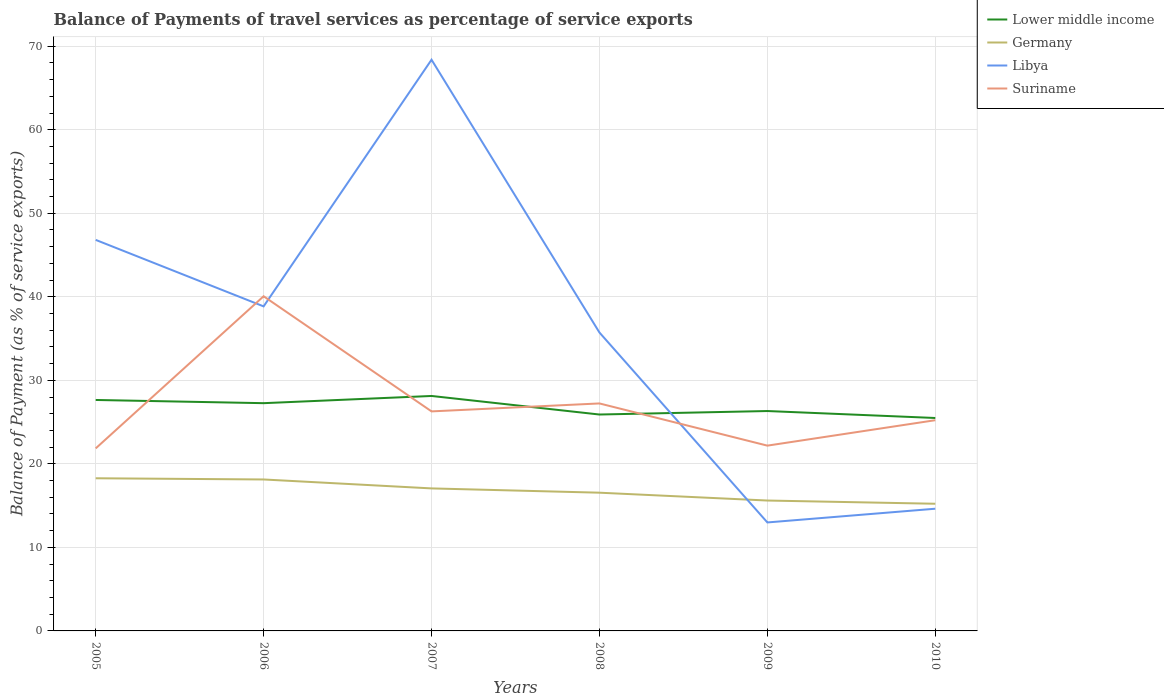Across all years, what is the maximum balance of payments of travel services in Germany?
Provide a short and direct response. 15.23. What is the total balance of payments of travel services in Lower middle income in the graph?
Offer a very short reply. 2.64. What is the difference between the highest and the second highest balance of payments of travel services in Suriname?
Your answer should be very brief. 18.22. Is the balance of payments of travel services in Libya strictly greater than the balance of payments of travel services in Lower middle income over the years?
Provide a succinct answer. No. How many lines are there?
Your answer should be compact. 4. What is the difference between two consecutive major ticks on the Y-axis?
Your answer should be very brief. 10. Are the values on the major ticks of Y-axis written in scientific E-notation?
Offer a terse response. No. Does the graph contain any zero values?
Ensure brevity in your answer.  No. Does the graph contain grids?
Offer a terse response. Yes. Where does the legend appear in the graph?
Ensure brevity in your answer.  Top right. How many legend labels are there?
Provide a succinct answer. 4. What is the title of the graph?
Ensure brevity in your answer.  Balance of Payments of travel services as percentage of service exports. What is the label or title of the X-axis?
Make the answer very short. Years. What is the label or title of the Y-axis?
Your answer should be compact. Balance of Payment (as % of service exports). What is the Balance of Payment (as % of service exports) in Lower middle income in 2005?
Your response must be concise. 27.65. What is the Balance of Payment (as % of service exports) in Germany in 2005?
Keep it short and to the point. 18.28. What is the Balance of Payment (as % of service exports) in Libya in 2005?
Keep it short and to the point. 46.82. What is the Balance of Payment (as % of service exports) in Suriname in 2005?
Make the answer very short. 21.85. What is the Balance of Payment (as % of service exports) of Lower middle income in 2006?
Your answer should be compact. 27.27. What is the Balance of Payment (as % of service exports) in Germany in 2006?
Ensure brevity in your answer.  18.13. What is the Balance of Payment (as % of service exports) in Libya in 2006?
Your response must be concise. 38.85. What is the Balance of Payment (as % of service exports) of Suriname in 2006?
Your answer should be very brief. 40.07. What is the Balance of Payment (as % of service exports) in Lower middle income in 2007?
Provide a short and direct response. 28.13. What is the Balance of Payment (as % of service exports) of Germany in 2007?
Your answer should be very brief. 17.06. What is the Balance of Payment (as % of service exports) in Libya in 2007?
Your answer should be very brief. 68.39. What is the Balance of Payment (as % of service exports) of Suriname in 2007?
Offer a very short reply. 26.28. What is the Balance of Payment (as % of service exports) in Lower middle income in 2008?
Provide a short and direct response. 25.91. What is the Balance of Payment (as % of service exports) in Germany in 2008?
Your response must be concise. 16.55. What is the Balance of Payment (as % of service exports) of Libya in 2008?
Give a very brief answer. 35.72. What is the Balance of Payment (as % of service exports) in Suriname in 2008?
Provide a succinct answer. 27.23. What is the Balance of Payment (as % of service exports) in Lower middle income in 2009?
Offer a very short reply. 26.33. What is the Balance of Payment (as % of service exports) of Germany in 2009?
Give a very brief answer. 15.61. What is the Balance of Payment (as % of service exports) in Libya in 2009?
Provide a succinct answer. 12.99. What is the Balance of Payment (as % of service exports) in Suriname in 2009?
Keep it short and to the point. 22.18. What is the Balance of Payment (as % of service exports) in Lower middle income in 2010?
Ensure brevity in your answer.  25.49. What is the Balance of Payment (as % of service exports) in Germany in 2010?
Keep it short and to the point. 15.23. What is the Balance of Payment (as % of service exports) in Libya in 2010?
Offer a terse response. 14.63. What is the Balance of Payment (as % of service exports) in Suriname in 2010?
Offer a terse response. 25.23. Across all years, what is the maximum Balance of Payment (as % of service exports) in Lower middle income?
Offer a very short reply. 28.13. Across all years, what is the maximum Balance of Payment (as % of service exports) of Germany?
Your response must be concise. 18.28. Across all years, what is the maximum Balance of Payment (as % of service exports) of Libya?
Keep it short and to the point. 68.39. Across all years, what is the maximum Balance of Payment (as % of service exports) of Suriname?
Your answer should be compact. 40.07. Across all years, what is the minimum Balance of Payment (as % of service exports) in Lower middle income?
Your answer should be very brief. 25.49. Across all years, what is the minimum Balance of Payment (as % of service exports) of Germany?
Make the answer very short. 15.23. Across all years, what is the minimum Balance of Payment (as % of service exports) in Libya?
Ensure brevity in your answer.  12.99. Across all years, what is the minimum Balance of Payment (as % of service exports) in Suriname?
Keep it short and to the point. 21.85. What is the total Balance of Payment (as % of service exports) in Lower middle income in the graph?
Offer a terse response. 160.78. What is the total Balance of Payment (as % of service exports) in Germany in the graph?
Your answer should be compact. 100.86. What is the total Balance of Payment (as % of service exports) of Libya in the graph?
Offer a terse response. 217.4. What is the total Balance of Payment (as % of service exports) of Suriname in the graph?
Ensure brevity in your answer.  162.85. What is the difference between the Balance of Payment (as % of service exports) in Lower middle income in 2005 and that in 2006?
Offer a terse response. 0.38. What is the difference between the Balance of Payment (as % of service exports) in Germany in 2005 and that in 2006?
Your answer should be very brief. 0.14. What is the difference between the Balance of Payment (as % of service exports) in Libya in 2005 and that in 2006?
Offer a terse response. 7.96. What is the difference between the Balance of Payment (as % of service exports) of Suriname in 2005 and that in 2006?
Ensure brevity in your answer.  -18.22. What is the difference between the Balance of Payment (as % of service exports) of Lower middle income in 2005 and that in 2007?
Offer a terse response. -0.48. What is the difference between the Balance of Payment (as % of service exports) in Germany in 2005 and that in 2007?
Keep it short and to the point. 1.21. What is the difference between the Balance of Payment (as % of service exports) in Libya in 2005 and that in 2007?
Offer a terse response. -21.57. What is the difference between the Balance of Payment (as % of service exports) in Suriname in 2005 and that in 2007?
Give a very brief answer. -4.43. What is the difference between the Balance of Payment (as % of service exports) in Lower middle income in 2005 and that in 2008?
Your answer should be very brief. 1.74. What is the difference between the Balance of Payment (as % of service exports) of Germany in 2005 and that in 2008?
Offer a terse response. 1.73. What is the difference between the Balance of Payment (as % of service exports) of Libya in 2005 and that in 2008?
Provide a succinct answer. 11.09. What is the difference between the Balance of Payment (as % of service exports) of Suriname in 2005 and that in 2008?
Provide a short and direct response. -5.38. What is the difference between the Balance of Payment (as % of service exports) in Lower middle income in 2005 and that in 2009?
Offer a very short reply. 1.32. What is the difference between the Balance of Payment (as % of service exports) of Germany in 2005 and that in 2009?
Your answer should be compact. 2.67. What is the difference between the Balance of Payment (as % of service exports) of Libya in 2005 and that in 2009?
Your answer should be compact. 33.83. What is the difference between the Balance of Payment (as % of service exports) of Suriname in 2005 and that in 2009?
Ensure brevity in your answer.  -0.33. What is the difference between the Balance of Payment (as % of service exports) of Lower middle income in 2005 and that in 2010?
Your answer should be very brief. 2.16. What is the difference between the Balance of Payment (as % of service exports) in Germany in 2005 and that in 2010?
Keep it short and to the point. 3.05. What is the difference between the Balance of Payment (as % of service exports) in Libya in 2005 and that in 2010?
Offer a very short reply. 32.19. What is the difference between the Balance of Payment (as % of service exports) of Suriname in 2005 and that in 2010?
Offer a terse response. -3.38. What is the difference between the Balance of Payment (as % of service exports) of Lower middle income in 2006 and that in 2007?
Your answer should be compact. -0.86. What is the difference between the Balance of Payment (as % of service exports) in Germany in 2006 and that in 2007?
Give a very brief answer. 1.07. What is the difference between the Balance of Payment (as % of service exports) in Libya in 2006 and that in 2007?
Give a very brief answer. -29.53. What is the difference between the Balance of Payment (as % of service exports) of Suriname in 2006 and that in 2007?
Your response must be concise. 13.79. What is the difference between the Balance of Payment (as % of service exports) of Lower middle income in 2006 and that in 2008?
Offer a terse response. 1.36. What is the difference between the Balance of Payment (as % of service exports) in Germany in 2006 and that in 2008?
Provide a short and direct response. 1.58. What is the difference between the Balance of Payment (as % of service exports) of Libya in 2006 and that in 2008?
Your answer should be very brief. 3.13. What is the difference between the Balance of Payment (as % of service exports) of Suriname in 2006 and that in 2008?
Keep it short and to the point. 12.83. What is the difference between the Balance of Payment (as % of service exports) of Lower middle income in 2006 and that in 2009?
Give a very brief answer. 0.94. What is the difference between the Balance of Payment (as % of service exports) of Germany in 2006 and that in 2009?
Your answer should be very brief. 2.52. What is the difference between the Balance of Payment (as % of service exports) in Libya in 2006 and that in 2009?
Offer a very short reply. 25.87. What is the difference between the Balance of Payment (as % of service exports) of Suriname in 2006 and that in 2009?
Make the answer very short. 17.88. What is the difference between the Balance of Payment (as % of service exports) of Lower middle income in 2006 and that in 2010?
Give a very brief answer. 1.77. What is the difference between the Balance of Payment (as % of service exports) of Germany in 2006 and that in 2010?
Make the answer very short. 2.91. What is the difference between the Balance of Payment (as % of service exports) in Libya in 2006 and that in 2010?
Your response must be concise. 24.22. What is the difference between the Balance of Payment (as % of service exports) of Suriname in 2006 and that in 2010?
Offer a terse response. 14.84. What is the difference between the Balance of Payment (as % of service exports) of Lower middle income in 2007 and that in 2008?
Your answer should be compact. 2.22. What is the difference between the Balance of Payment (as % of service exports) of Germany in 2007 and that in 2008?
Your response must be concise. 0.51. What is the difference between the Balance of Payment (as % of service exports) in Libya in 2007 and that in 2008?
Offer a very short reply. 32.66. What is the difference between the Balance of Payment (as % of service exports) of Suriname in 2007 and that in 2008?
Offer a terse response. -0.95. What is the difference between the Balance of Payment (as % of service exports) in Lower middle income in 2007 and that in 2009?
Make the answer very short. 1.8. What is the difference between the Balance of Payment (as % of service exports) in Germany in 2007 and that in 2009?
Your answer should be compact. 1.45. What is the difference between the Balance of Payment (as % of service exports) of Libya in 2007 and that in 2009?
Make the answer very short. 55.4. What is the difference between the Balance of Payment (as % of service exports) in Suriname in 2007 and that in 2009?
Give a very brief answer. 4.1. What is the difference between the Balance of Payment (as % of service exports) in Lower middle income in 2007 and that in 2010?
Offer a very short reply. 2.64. What is the difference between the Balance of Payment (as % of service exports) in Germany in 2007 and that in 2010?
Offer a very short reply. 1.84. What is the difference between the Balance of Payment (as % of service exports) of Libya in 2007 and that in 2010?
Your answer should be very brief. 53.76. What is the difference between the Balance of Payment (as % of service exports) of Suriname in 2007 and that in 2010?
Your response must be concise. 1.05. What is the difference between the Balance of Payment (as % of service exports) in Lower middle income in 2008 and that in 2009?
Offer a very short reply. -0.42. What is the difference between the Balance of Payment (as % of service exports) in Germany in 2008 and that in 2009?
Your answer should be compact. 0.94. What is the difference between the Balance of Payment (as % of service exports) in Libya in 2008 and that in 2009?
Offer a terse response. 22.74. What is the difference between the Balance of Payment (as % of service exports) of Suriname in 2008 and that in 2009?
Ensure brevity in your answer.  5.05. What is the difference between the Balance of Payment (as % of service exports) of Lower middle income in 2008 and that in 2010?
Provide a succinct answer. 0.42. What is the difference between the Balance of Payment (as % of service exports) in Germany in 2008 and that in 2010?
Your response must be concise. 1.32. What is the difference between the Balance of Payment (as % of service exports) in Libya in 2008 and that in 2010?
Make the answer very short. 21.09. What is the difference between the Balance of Payment (as % of service exports) in Suriname in 2008 and that in 2010?
Offer a terse response. 2.01. What is the difference between the Balance of Payment (as % of service exports) in Lower middle income in 2009 and that in 2010?
Offer a terse response. 0.83. What is the difference between the Balance of Payment (as % of service exports) of Germany in 2009 and that in 2010?
Make the answer very short. 0.38. What is the difference between the Balance of Payment (as % of service exports) of Libya in 2009 and that in 2010?
Your answer should be very brief. -1.64. What is the difference between the Balance of Payment (as % of service exports) in Suriname in 2009 and that in 2010?
Offer a very short reply. -3.04. What is the difference between the Balance of Payment (as % of service exports) of Lower middle income in 2005 and the Balance of Payment (as % of service exports) of Germany in 2006?
Your answer should be compact. 9.52. What is the difference between the Balance of Payment (as % of service exports) in Lower middle income in 2005 and the Balance of Payment (as % of service exports) in Libya in 2006?
Offer a terse response. -11.2. What is the difference between the Balance of Payment (as % of service exports) of Lower middle income in 2005 and the Balance of Payment (as % of service exports) of Suriname in 2006?
Your answer should be very brief. -12.42. What is the difference between the Balance of Payment (as % of service exports) of Germany in 2005 and the Balance of Payment (as % of service exports) of Libya in 2006?
Keep it short and to the point. -20.58. What is the difference between the Balance of Payment (as % of service exports) of Germany in 2005 and the Balance of Payment (as % of service exports) of Suriname in 2006?
Keep it short and to the point. -21.79. What is the difference between the Balance of Payment (as % of service exports) in Libya in 2005 and the Balance of Payment (as % of service exports) in Suriname in 2006?
Provide a succinct answer. 6.75. What is the difference between the Balance of Payment (as % of service exports) of Lower middle income in 2005 and the Balance of Payment (as % of service exports) of Germany in 2007?
Your answer should be compact. 10.59. What is the difference between the Balance of Payment (as % of service exports) in Lower middle income in 2005 and the Balance of Payment (as % of service exports) in Libya in 2007?
Keep it short and to the point. -40.74. What is the difference between the Balance of Payment (as % of service exports) of Lower middle income in 2005 and the Balance of Payment (as % of service exports) of Suriname in 2007?
Give a very brief answer. 1.37. What is the difference between the Balance of Payment (as % of service exports) of Germany in 2005 and the Balance of Payment (as % of service exports) of Libya in 2007?
Your answer should be very brief. -50.11. What is the difference between the Balance of Payment (as % of service exports) in Germany in 2005 and the Balance of Payment (as % of service exports) in Suriname in 2007?
Your response must be concise. -8.01. What is the difference between the Balance of Payment (as % of service exports) of Libya in 2005 and the Balance of Payment (as % of service exports) of Suriname in 2007?
Your response must be concise. 20.53. What is the difference between the Balance of Payment (as % of service exports) in Lower middle income in 2005 and the Balance of Payment (as % of service exports) in Germany in 2008?
Give a very brief answer. 11.1. What is the difference between the Balance of Payment (as % of service exports) of Lower middle income in 2005 and the Balance of Payment (as % of service exports) of Libya in 2008?
Provide a short and direct response. -8.07. What is the difference between the Balance of Payment (as % of service exports) in Lower middle income in 2005 and the Balance of Payment (as % of service exports) in Suriname in 2008?
Offer a very short reply. 0.42. What is the difference between the Balance of Payment (as % of service exports) in Germany in 2005 and the Balance of Payment (as % of service exports) in Libya in 2008?
Provide a short and direct response. -17.45. What is the difference between the Balance of Payment (as % of service exports) in Germany in 2005 and the Balance of Payment (as % of service exports) in Suriname in 2008?
Provide a short and direct response. -8.96. What is the difference between the Balance of Payment (as % of service exports) of Libya in 2005 and the Balance of Payment (as % of service exports) of Suriname in 2008?
Ensure brevity in your answer.  19.58. What is the difference between the Balance of Payment (as % of service exports) in Lower middle income in 2005 and the Balance of Payment (as % of service exports) in Germany in 2009?
Keep it short and to the point. 12.04. What is the difference between the Balance of Payment (as % of service exports) in Lower middle income in 2005 and the Balance of Payment (as % of service exports) in Libya in 2009?
Your response must be concise. 14.66. What is the difference between the Balance of Payment (as % of service exports) in Lower middle income in 2005 and the Balance of Payment (as % of service exports) in Suriname in 2009?
Provide a short and direct response. 5.47. What is the difference between the Balance of Payment (as % of service exports) in Germany in 2005 and the Balance of Payment (as % of service exports) in Libya in 2009?
Your answer should be compact. 5.29. What is the difference between the Balance of Payment (as % of service exports) of Germany in 2005 and the Balance of Payment (as % of service exports) of Suriname in 2009?
Provide a short and direct response. -3.91. What is the difference between the Balance of Payment (as % of service exports) in Libya in 2005 and the Balance of Payment (as % of service exports) in Suriname in 2009?
Ensure brevity in your answer.  24.63. What is the difference between the Balance of Payment (as % of service exports) of Lower middle income in 2005 and the Balance of Payment (as % of service exports) of Germany in 2010?
Your answer should be very brief. 12.43. What is the difference between the Balance of Payment (as % of service exports) of Lower middle income in 2005 and the Balance of Payment (as % of service exports) of Libya in 2010?
Your response must be concise. 13.02. What is the difference between the Balance of Payment (as % of service exports) of Lower middle income in 2005 and the Balance of Payment (as % of service exports) of Suriname in 2010?
Your response must be concise. 2.42. What is the difference between the Balance of Payment (as % of service exports) in Germany in 2005 and the Balance of Payment (as % of service exports) in Libya in 2010?
Make the answer very short. 3.65. What is the difference between the Balance of Payment (as % of service exports) of Germany in 2005 and the Balance of Payment (as % of service exports) of Suriname in 2010?
Your answer should be very brief. -6.95. What is the difference between the Balance of Payment (as % of service exports) in Libya in 2005 and the Balance of Payment (as % of service exports) in Suriname in 2010?
Your response must be concise. 21.59. What is the difference between the Balance of Payment (as % of service exports) of Lower middle income in 2006 and the Balance of Payment (as % of service exports) of Germany in 2007?
Provide a succinct answer. 10.2. What is the difference between the Balance of Payment (as % of service exports) of Lower middle income in 2006 and the Balance of Payment (as % of service exports) of Libya in 2007?
Make the answer very short. -41.12. What is the difference between the Balance of Payment (as % of service exports) in Lower middle income in 2006 and the Balance of Payment (as % of service exports) in Suriname in 2007?
Provide a short and direct response. 0.98. What is the difference between the Balance of Payment (as % of service exports) in Germany in 2006 and the Balance of Payment (as % of service exports) in Libya in 2007?
Your answer should be very brief. -50.25. What is the difference between the Balance of Payment (as % of service exports) of Germany in 2006 and the Balance of Payment (as % of service exports) of Suriname in 2007?
Your answer should be compact. -8.15. What is the difference between the Balance of Payment (as % of service exports) in Libya in 2006 and the Balance of Payment (as % of service exports) in Suriname in 2007?
Keep it short and to the point. 12.57. What is the difference between the Balance of Payment (as % of service exports) of Lower middle income in 2006 and the Balance of Payment (as % of service exports) of Germany in 2008?
Your answer should be very brief. 10.72. What is the difference between the Balance of Payment (as % of service exports) in Lower middle income in 2006 and the Balance of Payment (as % of service exports) in Libya in 2008?
Offer a very short reply. -8.46. What is the difference between the Balance of Payment (as % of service exports) of Lower middle income in 2006 and the Balance of Payment (as % of service exports) of Suriname in 2008?
Provide a short and direct response. 0.03. What is the difference between the Balance of Payment (as % of service exports) in Germany in 2006 and the Balance of Payment (as % of service exports) in Libya in 2008?
Your answer should be compact. -17.59. What is the difference between the Balance of Payment (as % of service exports) in Germany in 2006 and the Balance of Payment (as % of service exports) in Suriname in 2008?
Make the answer very short. -9.1. What is the difference between the Balance of Payment (as % of service exports) in Libya in 2006 and the Balance of Payment (as % of service exports) in Suriname in 2008?
Provide a short and direct response. 11.62. What is the difference between the Balance of Payment (as % of service exports) in Lower middle income in 2006 and the Balance of Payment (as % of service exports) in Germany in 2009?
Your answer should be compact. 11.66. What is the difference between the Balance of Payment (as % of service exports) in Lower middle income in 2006 and the Balance of Payment (as % of service exports) in Libya in 2009?
Ensure brevity in your answer.  14.28. What is the difference between the Balance of Payment (as % of service exports) of Lower middle income in 2006 and the Balance of Payment (as % of service exports) of Suriname in 2009?
Keep it short and to the point. 5.08. What is the difference between the Balance of Payment (as % of service exports) of Germany in 2006 and the Balance of Payment (as % of service exports) of Libya in 2009?
Your response must be concise. 5.15. What is the difference between the Balance of Payment (as % of service exports) in Germany in 2006 and the Balance of Payment (as % of service exports) in Suriname in 2009?
Offer a terse response. -4.05. What is the difference between the Balance of Payment (as % of service exports) in Libya in 2006 and the Balance of Payment (as % of service exports) in Suriname in 2009?
Offer a terse response. 16.67. What is the difference between the Balance of Payment (as % of service exports) of Lower middle income in 2006 and the Balance of Payment (as % of service exports) of Germany in 2010?
Provide a short and direct response. 12.04. What is the difference between the Balance of Payment (as % of service exports) of Lower middle income in 2006 and the Balance of Payment (as % of service exports) of Libya in 2010?
Provide a succinct answer. 12.64. What is the difference between the Balance of Payment (as % of service exports) of Lower middle income in 2006 and the Balance of Payment (as % of service exports) of Suriname in 2010?
Make the answer very short. 2.04. What is the difference between the Balance of Payment (as % of service exports) of Germany in 2006 and the Balance of Payment (as % of service exports) of Libya in 2010?
Keep it short and to the point. 3.5. What is the difference between the Balance of Payment (as % of service exports) of Germany in 2006 and the Balance of Payment (as % of service exports) of Suriname in 2010?
Your answer should be compact. -7.1. What is the difference between the Balance of Payment (as % of service exports) in Libya in 2006 and the Balance of Payment (as % of service exports) in Suriname in 2010?
Provide a succinct answer. 13.63. What is the difference between the Balance of Payment (as % of service exports) in Lower middle income in 2007 and the Balance of Payment (as % of service exports) in Germany in 2008?
Make the answer very short. 11.58. What is the difference between the Balance of Payment (as % of service exports) in Lower middle income in 2007 and the Balance of Payment (as % of service exports) in Libya in 2008?
Offer a very short reply. -7.59. What is the difference between the Balance of Payment (as % of service exports) in Lower middle income in 2007 and the Balance of Payment (as % of service exports) in Suriname in 2008?
Offer a very short reply. 0.9. What is the difference between the Balance of Payment (as % of service exports) in Germany in 2007 and the Balance of Payment (as % of service exports) in Libya in 2008?
Make the answer very short. -18.66. What is the difference between the Balance of Payment (as % of service exports) of Germany in 2007 and the Balance of Payment (as % of service exports) of Suriname in 2008?
Your answer should be very brief. -10.17. What is the difference between the Balance of Payment (as % of service exports) in Libya in 2007 and the Balance of Payment (as % of service exports) in Suriname in 2008?
Make the answer very short. 41.15. What is the difference between the Balance of Payment (as % of service exports) of Lower middle income in 2007 and the Balance of Payment (as % of service exports) of Germany in 2009?
Keep it short and to the point. 12.52. What is the difference between the Balance of Payment (as % of service exports) of Lower middle income in 2007 and the Balance of Payment (as % of service exports) of Libya in 2009?
Your answer should be very brief. 15.14. What is the difference between the Balance of Payment (as % of service exports) in Lower middle income in 2007 and the Balance of Payment (as % of service exports) in Suriname in 2009?
Offer a very short reply. 5.95. What is the difference between the Balance of Payment (as % of service exports) of Germany in 2007 and the Balance of Payment (as % of service exports) of Libya in 2009?
Give a very brief answer. 4.08. What is the difference between the Balance of Payment (as % of service exports) of Germany in 2007 and the Balance of Payment (as % of service exports) of Suriname in 2009?
Ensure brevity in your answer.  -5.12. What is the difference between the Balance of Payment (as % of service exports) in Libya in 2007 and the Balance of Payment (as % of service exports) in Suriname in 2009?
Provide a short and direct response. 46.2. What is the difference between the Balance of Payment (as % of service exports) of Lower middle income in 2007 and the Balance of Payment (as % of service exports) of Germany in 2010?
Provide a succinct answer. 12.9. What is the difference between the Balance of Payment (as % of service exports) of Lower middle income in 2007 and the Balance of Payment (as % of service exports) of Libya in 2010?
Your response must be concise. 13.5. What is the difference between the Balance of Payment (as % of service exports) of Lower middle income in 2007 and the Balance of Payment (as % of service exports) of Suriname in 2010?
Ensure brevity in your answer.  2.9. What is the difference between the Balance of Payment (as % of service exports) of Germany in 2007 and the Balance of Payment (as % of service exports) of Libya in 2010?
Your answer should be compact. 2.43. What is the difference between the Balance of Payment (as % of service exports) in Germany in 2007 and the Balance of Payment (as % of service exports) in Suriname in 2010?
Ensure brevity in your answer.  -8.17. What is the difference between the Balance of Payment (as % of service exports) in Libya in 2007 and the Balance of Payment (as % of service exports) in Suriname in 2010?
Your answer should be very brief. 43.16. What is the difference between the Balance of Payment (as % of service exports) of Lower middle income in 2008 and the Balance of Payment (as % of service exports) of Germany in 2009?
Make the answer very short. 10.3. What is the difference between the Balance of Payment (as % of service exports) in Lower middle income in 2008 and the Balance of Payment (as % of service exports) in Libya in 2009?
Provide a succinct answer. 12.92. What is the difference between the Balance of Payment (as % of service exports) of Lower middle income in 2008 and the Balance of Payment (as % of service exports) of Suriname in 2009?
Offer a very short reply. 3.72. What is the difference between the Balance of Payment (as % of service exports) of Germany in 2008 and the Balance of Payment (as % of service exports) of Libya in 2009?
Ensure brevity in your answer.  3.56. What is the difference between the Balance of Payment (as % of service exports) in Germany in 2008 and the Balance of Payment (as % of service exports) in Suriname in 2009?
Your answer should be very brief. -5.63. What is the difference between the Balance of Payment (as % of service exports) of Libya in 2008 and the Balance of Payment (as % of service exports) of Suriname in 2009?
Give a very brief answer. 13.54. What is the difference between the Balance of Payment (as % of service exports) of Lower middle income in 2008 and the Balance of Payment (as % of service exports) of Germany in 2010?
Your answer should be compact. 10.68. What is the difference between the Balance of Payment (as % of service exports) in Lower middle income in 2008 and the Balance of Payment (as % of service exports) in Libya in 2010?
Your answer should be compact. 11.28. What is the difference between the Balance of Payment (as % of service exports) of Lower middle income in 2008 and the Balance of Payment (as % of service exports) of Suriname in 2010?
Your response must be concise. 0.68. What is the difference between the Balance of Payment (as % of service exports) of Germany in 2008 and the Balance of Payment (as % of service exports) of Libya in 2010?
Ensure brevity in your answer.  1.92. What is the difference between the Balance of Payment (as % of service exports) in Germany in 2008 and the Balance of Payment (as % of service exports) in Suriname in 2010?
Make the answer very short. -8.68. What is the difference between the Balance of Payment (as % of service exports) in Libya in 2008 and the Balance of Payment (as % of service exports) in Suriname in 2010?
Ensure brevity in your answer.  10.5. What is the difference between the Balance of Payment (as % of service exports) of Lower middle income in 2009 and the Balance of Payment (as % of service exports) of Germany in 2010?
Offer a very short reply. 11.1. What is the difference between the Balance of Payment (as % of service exports) in Lower middle income in 2009 and the Balance of Payment (as % of service exports) in Libya in 2010?
Your response must be concise. 11.7. What is the difference between the Balance of Payment (as % of service exports) of Lower middle income in 2009 and the Balance of Payment (as % of service exports) of Suriname in 2010?
Ensure brevity in your answer.  1.1. What is the difference between the Balance of Payment (as % of service exports) of Germany in 2009 and the Balance of Payment (as % of service exports) of Libya in 2010?
Offer a very short reply. 0.98. What is the difference between the Balance of Payment (as % of service exports) in Germany in 2009 and the Balance of Payment (as % of service exports) in Suriname in 2010?
Offer a terse response. -9.62. What is the difference between the Balance of Payment (as % of service exports) in Libya in 2009 and the Balance of Payment (as % of service exports) in Suriname in 2010?
Ensure brevity in your answer.  -12.24. What is the average Balance of Payment (as % of service exports) of Lower middle income per year?
Your answer should be very brief. 26.8. What is the average Balance of Payment (as % of service exports) of Germany per year?
Your answer should be compact. 16.81. What is the average Balance of Payment (as % of service exports) in Libya per year?
Your answer should be very brief. 36.23. What is the average Balance of Payment (as % of service exports) in Suriname per year?
Keep it short and to the point. 27.14. In the year 2005, what is the difference between the Balance of Payment (as % of service exports) of Lower middle income and Balance of Payment (as % of service exports) of Germany?
Offer a terse response. 9.38. In the year 2005, what is the difference between the Balance of Payment (as % of service exports) of Lower middle income and Balance of Payment (as % of service exports) of Libya?
Your answer should be compact. -19.17. In the year 2005, what is the difference between the Balance of Payment (as % of service exports) of Lower middle income and Balance of Payment (as % of service exports) of Suriname?
Offer a very short reply. 5.8. In the year 2005, what is the difference between the Balance of Payment (as % of service exports) of Germany and Balance of Payment (as % of service exports) of Libya?
Make the answer very short. -28.54. In the year 2005, what is the difference between the Balance of Payment (as % of service exports) of Germany and Balance of Payment (as % of service exports) of Suriname?
Keep it short and to the point. -3.58. In the year 2005, what is the difference between the Balance of Payment (as % of service exports) of Libya and Balance of Payment (as % of service exports) of Suriname?
Offer a very short reply. 24.96. In the year 2006, what is the difference between the Balance of Payment (as % of service exports) of Lower middle income and Balance of Payment (as % of service exports) of Germany?
Provide a short and direct response. 9.13. In the year 2006, what is the difference between the Balance of Payment (as % of service exports) of Lower middle income and Balance of Payment (as % of service exports) of Libya?
Offer a very short reply. -11.59. In the year 2006, what is the difference between the Balance of Payment (as % of service exports) in Lower middle income and Balance of Payment (as % of service exports) in Suriname?
Give a very brief answer. -12.8. In the year 2006, what is the difference between the Balance of Payment (as % of service exports) in Germany and Balance of Payment (as % of service exports) in Libya?
Offer a very short reply. -20.72. In the year 2006, what is the difference between the Balance of Payment (as % of service exports) of Germany and Balance of Payment (as % of service exports) of Suriname?
Your answer should be very brief. -21.94. In the year 2006, what is the difference between the Balance of Payment (as % of service exports) of Libya and Balance of Payment (as % of service exports) of Suriname?
Give a very brief answer. -1.21. In the year 2007, what is the difference between the Balance of Payment (as % of service exports) in Lower middle income and Balance of Payment (as % of service exports) in Germany?
Your answer should be compact. 11.07. In the year 2007, what is the difference between the Balance of Payment (as % of service exports) of Lower middle income and Balance of Payment (as % of service exports) of Libya?
Provide a short and direct response. -40.26. In the year 2007, what is the difference between the Balance of Payment (as % of service exports) of Lower middle income and Balance of Payment (as % of service exports) of Suriname?
Your answer should be very brief. 1.85. In the year 2007, what is the difference between the Balance of Payment (as % of service exports) in Germany and Balance of Payment (as % of service exports) in Libya?
Give a very brief answer. -51.32. In the year 2007, what is the difference between the Balance of Payment (as % of service exports) in Germany and Balance of Payment (as % of service exports) in Suriname?
Give a very brief answer. -9.22. In the year 2007, what is the difference between the Balance of Payment (as % of service exports) in Libya and Balance of Payment (as % of service exports) in Suriname?
Your response must be concise. 42.1. In the year 2008, what is the difference between the Balance of Payment (as % of service exports) in Lower middle income and Balance of Payment (as % of service exports) in Germany?
Your answer should be compact. 9.36. In the year 2008, what is the difference between the Balance of Payment (as % of service exports) in Lower middle income and Balance of Payment (as % of service exports) in Libya?
Provide a succinct answer. -9.82. In the year 2008, what is the difference between the Balance of Payment (as % of service exports) in Lower middle income and Balance of Payment (as % of service exports) in Suriname?
Make the answer very short. -1.33. In the year 2008, what is the difference between the Balance of Payment (as % of service exports) in Germany and Balance of Payment (as % of service exports) in Libya?
Make the answer very short. -19.18. In the year 2008, what is the difference between the Balance of Payment (as % of service exports) in Germany and Balance of Payment (as % of service exports) in Suriname?
Offer a terse response. -10.69. In the year 2008, what is the difference between the Balance of Payment (as % of service exports) in Libya and Balance of Payment (as % of service exports) in Suriname?
Offer a very short reply. 8.49. In the year 2009, what is the difference between the Balance of Payment (as % of service exports) in Lower middle income and Balance of Payment (as % of service exports) in Germany?
Ensure brevity in your answer.  10.72. In the year 2009, what is the difference between the Balance of Payment (as % of service exports) of Lower middle income and Balance of Payment (as % of service exports) of Libya?
Offer a terse response. 13.34. In the year 2009, what is the difference between the Balance of Payment (as % of service exports) in Lower middle income and Balance of Payment (as % of service exports) in Suriname?
Ensure brevity in your answer.  4.14. In the year 2009, what is the difference between the Balance of Payment (as % of service exports) in Germany and Balance of Payment (as % of service exports) in Libya?
Your answer should be very brief. 2.62. In the year 2009, what is the difference between the Balance of Payment (as % of service exports) in Germany and Balance of Payment (as % of service exports) in Suriname?
Give a very brief answer. -6.57. In the year 2009, what is the difference between the Balance of Payment (as % of service exports) of Libya and Balance of Payment (as % of service exports) of Suriname?
Make the answer very short. -9.2. In the year 2010, what is the difference between the Balance of Payment (as % of service exports) of Lower middle income and Balance of Payment (as % of service exports) of Germany?
Your answer should be compact. 10.27. In the year 2010, what is the difference between the Balance of Payment (as % of service exports) of Lower middle income and Balance of Payment (as % of service exports) of Libya?
Offer a terse response. 10.86. In the year 2010, what is the difference between the Balance of Payment (as % of service exports) in Lower middle income and Balance of Payment (as % of service exports) in Suriname?
Offer a terse response. 0.26. In the year 2010, what is the difference between the Balance of Payment (as % of service exports) of Germany and Balance of Payment (as % of service exports) of Libya?
Your answer should be very brief. 0.6. In the year 2010, what is the difference between the Balance of Payment (as % of service exports) of Germany and Balance of Payment (as % of service exports) of Suriname?
Your answer should be very brief. -10. In the year 2010, what is the difference between the Balance of Payment (as % of service exports) in Libya and Balance of Payment (as % of service exports) in Suriname?
Offer a terse response. -10.6. What is the ratio of the Balance of Payment (as % of service exports) in Lower middle income in 2005 to that in 2006?
Your response must be concise. 1.01. What is the ratio of the Balance of Payment (as % of service exports) of Germany in 2005 to that in 2006?
Offer a terse response. 1.01. What is the ratio of the Balance of Payment (as % of service exports) of Libya in 2005 to that in 2006?
Provide a succinct answer. 1.2. What is the ratio of the Balance of Payment (as % of service exports) in Suriname in 2005 to that in 2006?
Offer a terse response. 0.55. What is the ratio of the Balance of Payment (as % of service exports) of Germany in 2005 to that in 2007?
Provide a succinct answer. 1.07. What is the ratio of the Balance of Payment (as % of service exports) of Libya in 2005 to that in 2007?
Provide a succinct answer. 0.68. What is the ratio of the Balance of Payment (as % of service exports) of Suriname in 2005 to that in 2007?
Your answer should be very brief. 0.83. What is the ratio of the Balance of Payment (as % of service exports) in Lower middle income in 2005 to that in 2008?
Ensure brevity in your answer.  1.07. What is the ratio of the Balance of Payment (as % of service exports) in Germany in 2005 to that in 2008?
Offer a very short reply. 1.1. What is the ratio of the Balance of Payment (as % of service exports) in Libya in 2005 to that in 2008?
Provide a succinct answer. 1.31. What is the ratio of the Balance of Payment (as % of service exports) of Suriname in 2005 to that in 2008?
Ensure brevity in your answer.  0.8. What is the ratio of the Balance of Payment (as % of service exports) of Lower middle income in 2005 to that in 2009?
Offer a terse response. 1.05. What is the ratio of the Balance of Payment (as % of service exports) of Germany in 2005 to that in 2009?
Your answer should be compact. 1.17. What is the ratio of the Balance of Payment (as % of service exports) of Libya in 2005 to that in 2009?
Give a very brief answer. 3.6. What is the ratio of the Balance of Payment (as % of service exports) in Suriname in 2005 to that in 2009?
Provide a short and direct response. 0.99. What is the ratio of the Balance of Payment (as % of service exports) in Lower middle income in 2005 to that in 2010?
Give a very brief answer. 1.08. What is the ratio of the Balance of Payment (as % of service exports) in Germany in 2005 to that in 2010?
Give a very brief answer. 1.2. What is the ratio of the Balance of Payment (as % of service exports) of Libya in 2005 to that in 2010?
Provide a short and direct response. 3.2. What is the ratio of the Balance of Payment (as % of service exports) in Suriname in 2005 to that in 2010?
Provide a short and direct response. 0.87. What is the ratio of the Balance of Payment (as % of service exports) of Lower middle income in 2006 to that in 2007?
Keep it short and to the point. 0.97. What is the ratio of the Balance of Payment (as % of service exports) of Germany in 2006 to that in 2007?
Your answer should be very brief. 1.06. What is the ratio of the Balance of Payment (as % of service exports) in Libya in 2006 to that in 2007?
Ensure brevity in your answer.  0.57. What is the ratio of the Balance of Payment (as % of service exports) of Suriname in 2006 to that in 2007?
Your answer should be very brief. 1.52. What is the ratio of the Balance of Payment (as % of service exports) in Lower middle income in 2006 to that in 2008?
Your answer should be very brief. 1.05. What is the ratio of the Balance of Payment (as % of service exports) of Germany in 2006 to that in 2008?
Your response must be concise. 1.1. What is the ratio of the Balance of Payment (as % of service exports) of Libya in 2006 to that in 2008?
Your answer should be compact. 1.09. What is the ratio of the Balance of Payment (as % of service exports) in Suriname in 2006 to that in 2008?
Ensure brevity in your answer.  1.47. What is the ratio of the Balance of Payment (as % of service exports) in Lower middle income in 2006 to that in 2009?
Offer a terse response. 1.04. What is the ratio of the Balance of Payment (as % of service exports) of Germany in 2006 to that in 2009?
Make the answer very short. 1.16. What is the ratio of the Balance of Payment (as % of service exports) of Libya in 2006 to that in 2009?
Offer a terse response. 2.99. What is the ratio of the Balance of Payment (as % of service exports) in Suriname in 2006 to that in 2009?
Your answer should be compact. 1.81. What is the ratio of the Balance of Payment (as % of service exports) in Lower middle income in 2006 to that in 2010?
Your answer should be very brief. 1.07. What is the ratio of the Balance of Payment (as % of service exports) of Germany in 2006 to that in 2010?
Offer a very short reply. 1.19. What is the ratio of the Balance of Payment (as % of service exports) of Libya in 2006 to that in 2010?
Your answer should be compact. 2.66. What is the ratio of the Balance of Payment (as % of service exports) of Suriname in 2006 to that in 2010?
Your answer should be very brief. 1.59. What is the ratio of the Balance of Payment (as % of service exports) of Lower middle income in 2007 to that in 2008?
Ensure brevity in your answer.  1.09. What is the ratio of the Balance of Payment (as % of service exports) in Germany in 2007 to that in 2008?
Your response must be concise. 1.03. What is the ratio of the Balance of Payment (as % of service exports) in Libya in 2007 to that in 2008?
Make the answer very short. 1.91. What is the ratio of the Balance of Payment (as % of service exports) in Suriname in 2007 to that in 2008?
Offer a very short reply. 0.97. What is the ratio of the Balance of Payment (as % of service exports) of Lower middle income in 2007 to that in 2009?
Ensure brevity in your answer.  1.07. What is the ratio of the Balance of Payment (as % of service exports) of Germany in 2007 to that in 2009?
Your answer should be compact. 1.09. What is the ratio of the Balance of Payment (as % of service exports) in Libya in 2007 to that in 2009?
Ensure brevity in your answer.  5.27. What is the ratio of the Balance of Payment (as % of service exports) of Suriname in 2007 to that in 2009?
Your answer should be compact. 1.18. What is the ratio of the Balance of Payment (as % of service exports) of Lower middle income in 2007 to that in 2010?
Your answer should be compact. 1.1. What is the ratio of the Balance of Payment (as % of service exports) of Germany in 2007 to that in 2010?
Offer a very short reply. 1.12. What is the ratio of the Balance of Payment (as % of service exports) in Libya in 2007 to that in 2010?
Your response must be concise. 4.67. What is the ratio of the Balance of Payment (as % of service exports) in Suriname in 2007 to that in 2010?
Offer a terse response. 1.04. What is the ratio of the Balance of Payment (as % of service exports) of Lower middle income in 2008 to that in 2009?
Keep it short and to the point. 0.98. What is the ratio of the Balance of Payment (as % of service exports) of Germany in 2008 to that in 2009?
Provide a succinct answer. 1.06. What is the ratio of the Balance of Payment (as % of service exports) of Libya in 2008 to that in 2009?
Offer a terse response. 2.75. What is the ratio of the Balance of Payment (as % of service exports) in Suriname in 2008 to that in 2009?
Offer a terse response. 1.23. What is the ratio of the Balance of Payment (as % of service exports) in Lower middle income in 2008 to that in 2010?
Your response must be concise. 1.02. What is the ratio of the Balance of Payment (as % of service exports) in Germany in 2008 to that in 2010?
Offer a very short reply. 1.09. What is the ratio of the Balance of Payment (as % of service exports) of Libya in 2008 to that in 2010?
Make the answer very short. 2.44. What is the ratio of the Balance of Payment (as % of service exports) in Suriname in 2008 to that in 2010?
Ensure brevity in your answer.  1.08. What is the ratio of the Balance of Payment (as % of service exports) of Lower middle income in 2009 to that in 2010?
Make the answer very short. 1.03. What is the ratio of the Balance of Payment (as % of service exports) in Germany in 2009 to that in 2010?
Give a very brief answer. 1.03. What is the ratio of the Balance of Payment (as % of service exports) in Libya in 2009 to that in 2010?
Your answer should be compact. 0.89. What is the ratio of the Balance of Payment (as % of service exports) of Suriname in 2009 to that in 2010?
Make the answer very short. 0.88. What is the difference between the highest and the second highest Balance of Payment (as % of service exports) in Lower middle income?
Provide a short and direct response. 0.48. What is the difference between the highest and the second highest Balance of Payment (as % of service exports) in Germany?
Your answer should be very brief. 0.14. What is the difference between the highest and the second highest Balance of Payment (as % of service exports) of Libya?
Provide a succinct answer. 21.57. What is the difference between the highest and the second highest Balance of Payment (as % of service exports) in Suriname?
Ensure brevity in your answer.  12.83. What is the difference between the highest and the lowest Balance of Payment (as % of service exports) in Lower middle income?
Provide a succinct answer. 2.64. What is the difference between the highest and the lowest Balance of Payment (as % of service exports) of Germany?
Keep it short and to the point. 3.05. What is the difference between the highest and the lowest Balance of Payment (as % of service exports) in Libya?
Offer a very short reply. 55.4. What is the difference between the highest and the lowest Balance of Payment (as % of service exports) in Suriname?
Your answer should be compact. 18.22. 